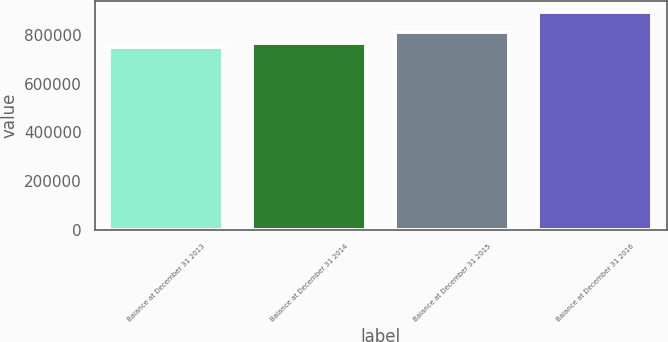Convert chart. <chart><loc_0><loc_0><loc_500><loc_500><bar_chart><fcel>Balance at December 31 2013<fcel>Balance at December 31 2014<fcel>Balance at December 31 2015<fcel>Balance at December 31 2016<nl><fcel>752941<fcel>767177<fcel>813414<fcel>895298<nl></chart> 